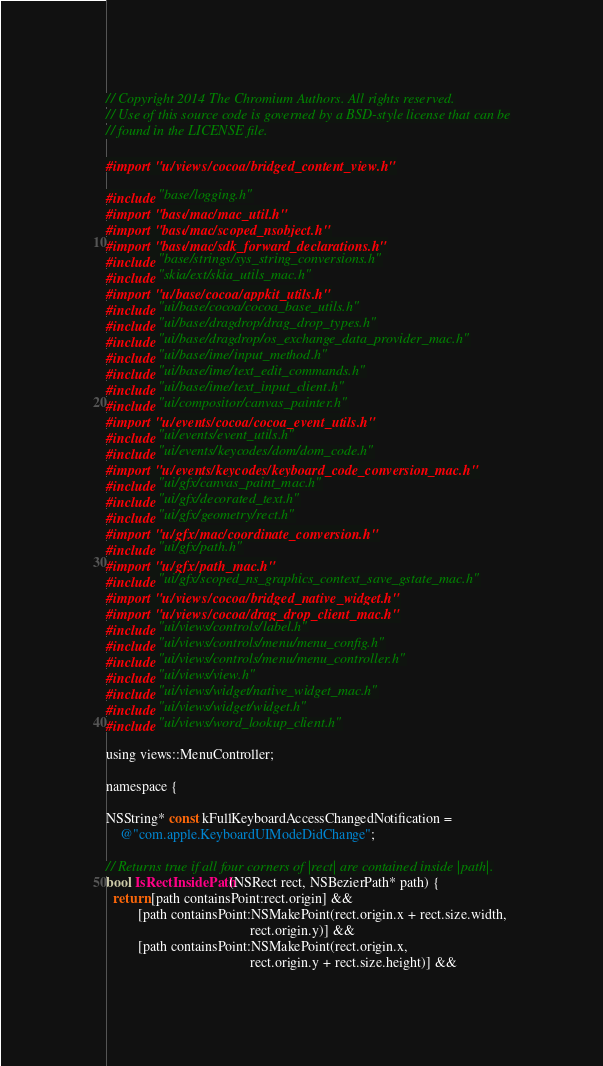Convert code to text. <code><loc_0><loc_0><loc_500><loc_500><_ObjectiveC_>// Copyright 2014 The Chromium Authors. All rights reserved.
// Use of this source code is governed by a BSD-style license that can be
// found in the LICENSE file.

#import "ui/views/cocoa/bridged_content_view.h"

#include "base/logging.h"
#import "base/mac/mac_util.h"
#import "base/mac/scoped_nsobject.h"
#import "base/mac/sdk_forward_declarations.h"
#include "base/strings/sys_string_conversions.h"
#include "skia/ext/skia_utils_mac.h"
#import "ui/base/cocoa/appkit_utils.h"
#include "ui/base/cocoa/cocoa_base_utils.h"
#include "ui/base/dragdrop/drag_drop_types.h"
#include "ui/base/dragdrop/os_exchange_data_provider_mac.h"
#include "ui/base/ime/input_method.h"
#include "ui/base/ime/text_edit_commands.h"
#include "ui/base/ime/text_input_client.h"
#include "ui/compositor/canvas_painter.h"
#import "ui/events/cocoa/cocoa_event_utils.h"
#include "ui/events/event_utils.h"
#include "ui/events/keycodes/dom/dom_code.h"
#import "ui/events/keycodes/keyboard_code_conversion_mac.h"
#include "ui/gfx/canvas_paint_mac.h"
#include "ui/gfx/decorated_text.h"
#include "ui/gfx/geometry/rect.h"
#import "ui/gfx/mac/coordinate_conversion.h"
#include "ui/gfx/path.h"
#import "ui/gfx/path_mac.h"
#include "ui/gfx/scoped_ns_graphics_context_save_gstate_mac.h"
#import "ui/views/cocoa/bridged_native_widget.h"
#import "ui/views/cocoa/drag_drop_client_mac.h"
#include "ui/views/controls/label.h"
#include "ui/views/controls/menu/menu_config.h"
#include "ui/views/controls/menu/menu_controller.h"
#include "ui/views/view.h"
#include "ui/views/widget/native_widget_mac.h"
#include "ui/views/widget/widget.h"
#include "ui/views/word_lookup_client.h"

using views::MenuController;

namespace {

NSString* const kFullKeyboardAccessChangedNotification =
    @"com.apple.KeyboardUIModeDidChange";

// Returns true if all four corners of |rect| are contained inside |path|.
bool IsRectInsidePath(NSRect rect, NSBezierPath* path) {
  return [path containsPoint:rect.origin] &&
         [path containsPoint:NSMakePoint(rect.origin.x + rect.size.width,
                                         rect.origin.y)] &&
         [path containsPoint:NSMakePoint(rect.origin.x,
                                         rect.origin.y + rect.size.height)] &&</code> 